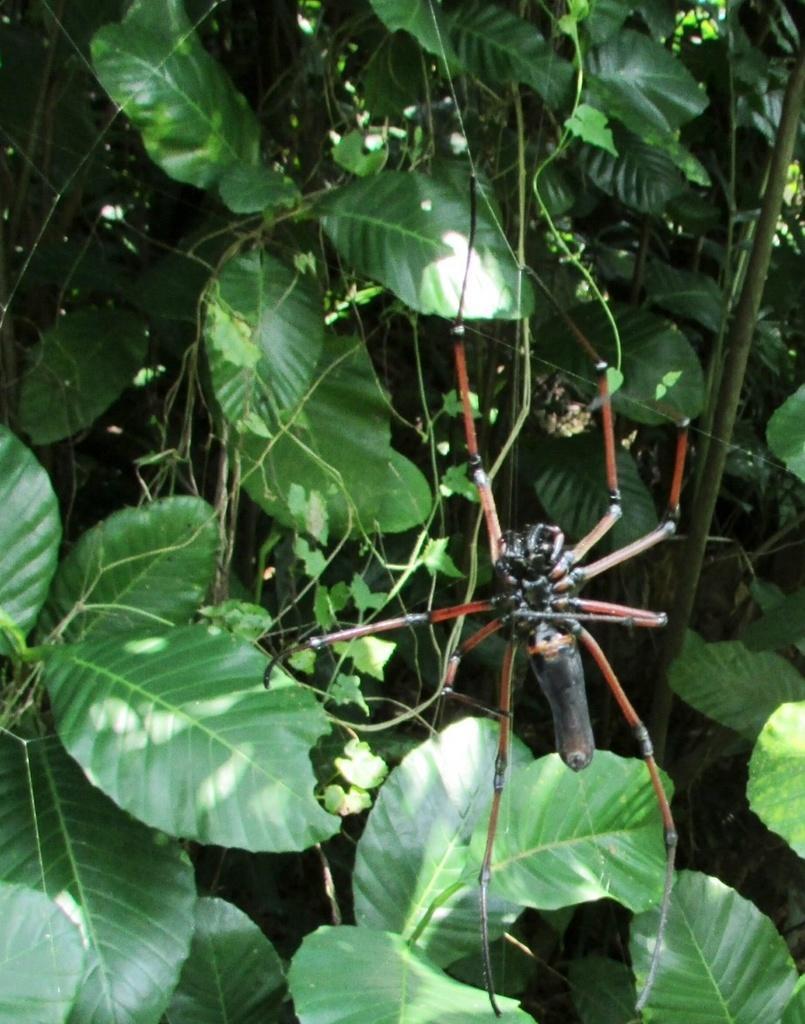Please provide a concise description of this image. In this picture we can see spider, green leaves and stems. 